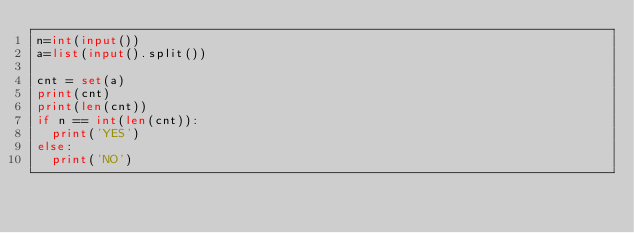<code> <loc_0><loc_0><loc_500><loc_500><_Python_>n=int(input())
a=list(input().split())

cnt = set(a)
print(cnt)
print(len(cnt))
if n == int(len(cnt)):
  print('YES')
else:
  print('NO')</code> 